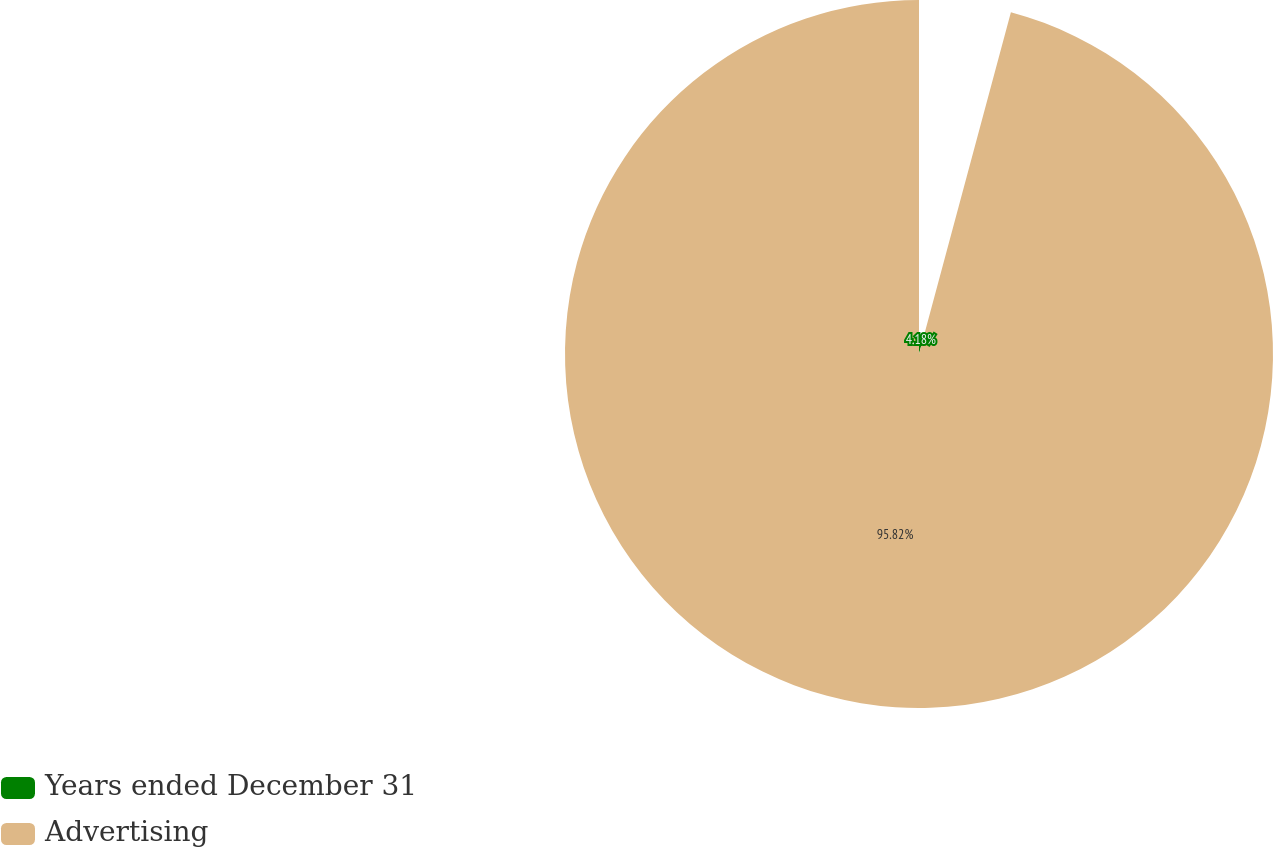Convert chart. <chart><loc_0><loc_0><loc_500><loc_500><pie_chart><fcel>Years ended December 31<fcel>Advertising<nl><fcel>4.18%<fcel>95.82%<nl></chart> 